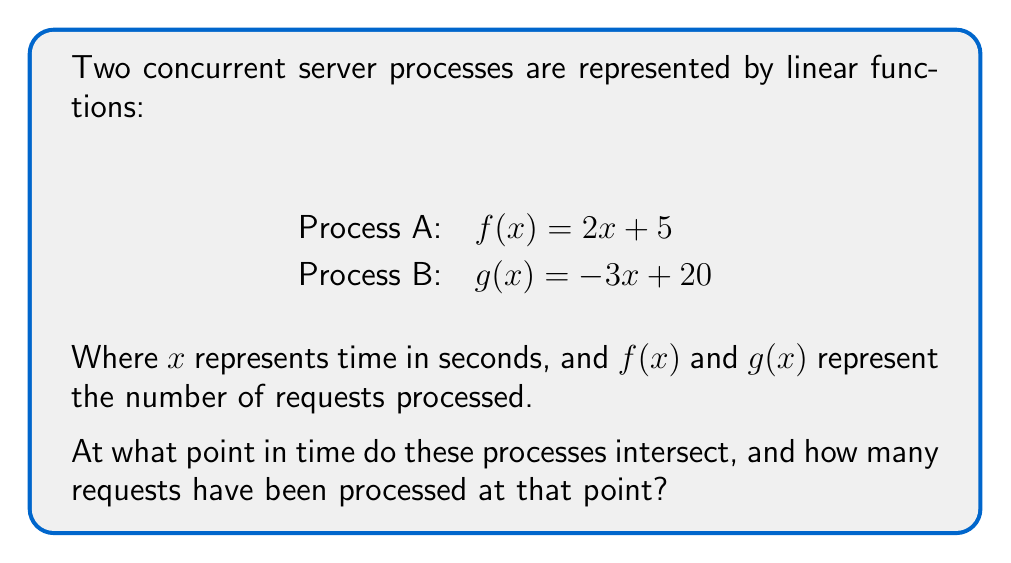Provide a solution to this math problem. To find the intersection point of these two linear functions, we need to solve the equation:

$f(x) = g(x)$

1. Substitute the given functions:
   $2x + 5 = -3x + 20$

2. Add $3x$ to both sides:
   $5x + 5 = 20$

3. Subtract 5 from both sides:
   $5x = 15$

4. Divide both sides by 5:
   $x = 3$

5. To find the number of requests processed at this point, substitute $x = 3$ into either function:
   $f(3) = 2(3) + 5 = 6 + 5 = 11$

Therefore, the processes intersect at $x = 3$ seconds, having processed 11 requests.
Answer: (3, 11) 